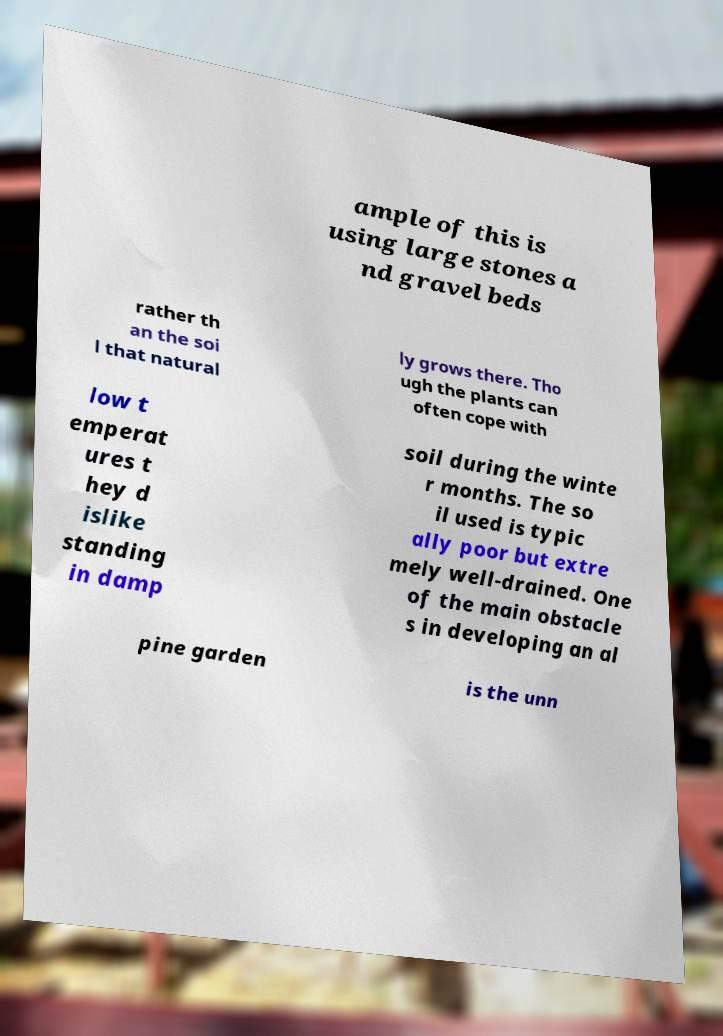Please read and relay the text visible in this image. What does it say? ample of this is using large stones a nd gravel beds rather th an the soi l that natural ly grows there. Tho ugh the plants can often cope with low t emperat ures t hey d islike standing in damp soil during the winte r months. The so il used is typic ally poor but extre mely well-drained. One of the main obstacle s in developing an al pine garden is the unn 